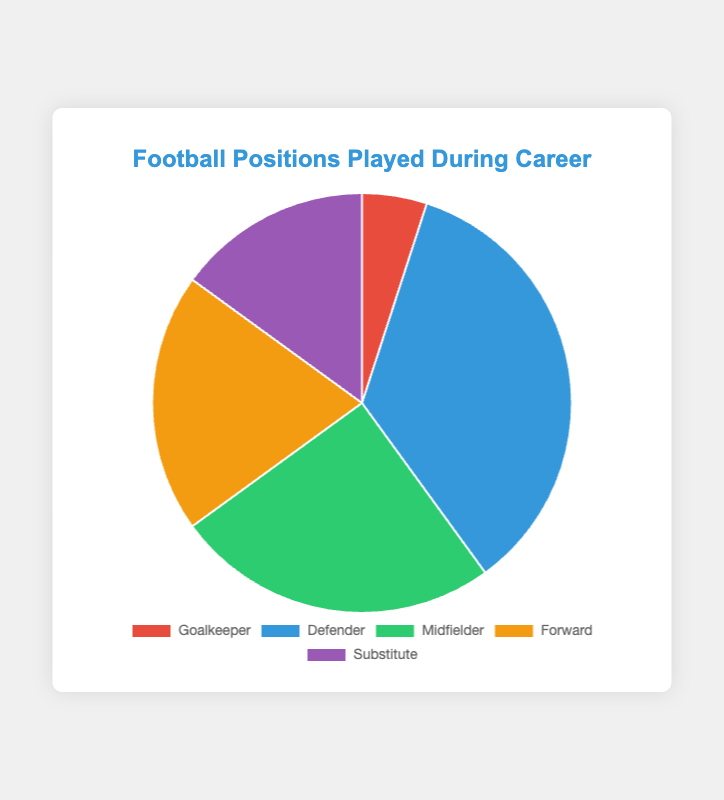What percentage of time was spent playing in offensive positions (Midfielder + Forward)? Sum the percentages for Midfielder and Forward: 25% + 20% = 45%
Answer: 45% Which position has the highest percentage, and what is it? The Defender has the highest percentage, which is 35%
Answer: Defender, 35% How much more time was spent as a Forward compared to a Goalkeeper? Subtract the percentage of Goalkeeper from Forward: 20% - 5% = 15%
Answer: 15% Out of the total time, what percentage was spent as a Defender and Substitute combined? Sum the percentages for Defender and Substitute: 35% + 15% = 50%
Answer: 50% Which position has the smallest representation, and what percentage is that? The Goalkeeper has the smallest representation with 5%
Answer: Goalkeeper, 5% Compare the percentage of time spent as a Midfielder to the percentage of time spent as a Substitute. The percentage of time spent as a Midfielder is 25%, compared to 15% for Substitute
Answer: Midfielder, 10% more Which two positions combined make up exactly half of the total playing time? Combining the percentages of Defender (35%) and Substitute (15%) gives exactly half of the total playing time: 35% + 15% = 50%
Answer: Defender and Substitute What is the difference in percentage points between playing as a Defender and as a Midfielder? Subtract the percentage of the Midfielder from the Defender: 35% - 25% = 10%
Answer: 10% If you visually group the positions by their colors, which color represents the Forward position? The Forward position is represented by the yellowish color in the chart
Answer: Yellow Excluding the Substitute position, what percentage of time was spent actively playing on the field? Subtract the Substitute percentage from 100%: 100% - 15% = 85%
Answer: 85% 